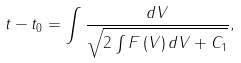Convert formula to latex. <formula><loc_0><loc_0><loc_500><loc_500>t - t _ { 0 } = \int \frac { d V } { \sqrt { 2 \int F \left ( V \right ) d V + C _ { 1 } } } ,</formula> 